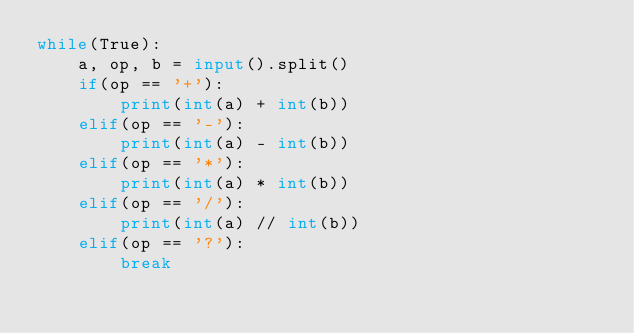<code> <loc_0><loc_0><loc_500><loc_500><_Python_>while(True):
    a, op, b = input().split()
    if(op == '+'):
        print(int(a) + int(b))
    elif(op == '-'):
        print(int(a) - int(b))
    elif(op == '*'):
        print(int(a) * int(b))
    elif(op == '/'):
        print(int(a) // int(b))
    elif(op == '?'):
        break
</code> 